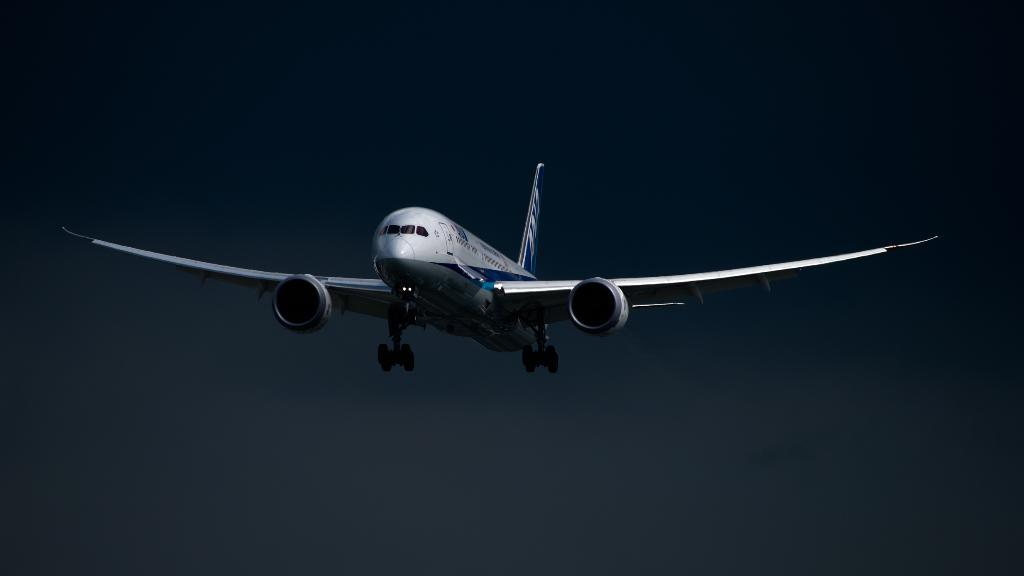What is the main subject of the image? The main subject of the image is an airplane. What is the airplane doing in the image? The airplane is flying in the sky. What type of twig can be seen hanging from the airplane in the image? There is no twig present in the image; it features an airplane flying in the sky. 